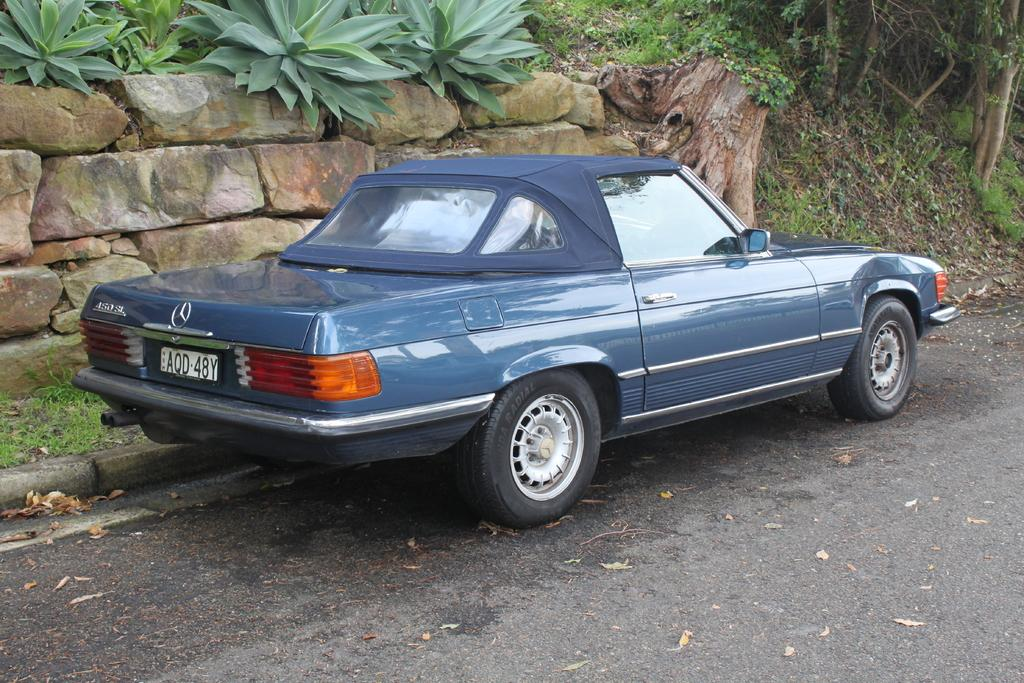What color is the car in the image? The car in the image is blue. Where is the car located in the image? The car is parked on the road in the image. What can be seen in the background of the image? Rocks, plants, and trees are visible in the background of the image. What is at the bottom of the image? There is a road at the bottom of the image. What type of tub is visible in the image? There is no tub present in the image. 